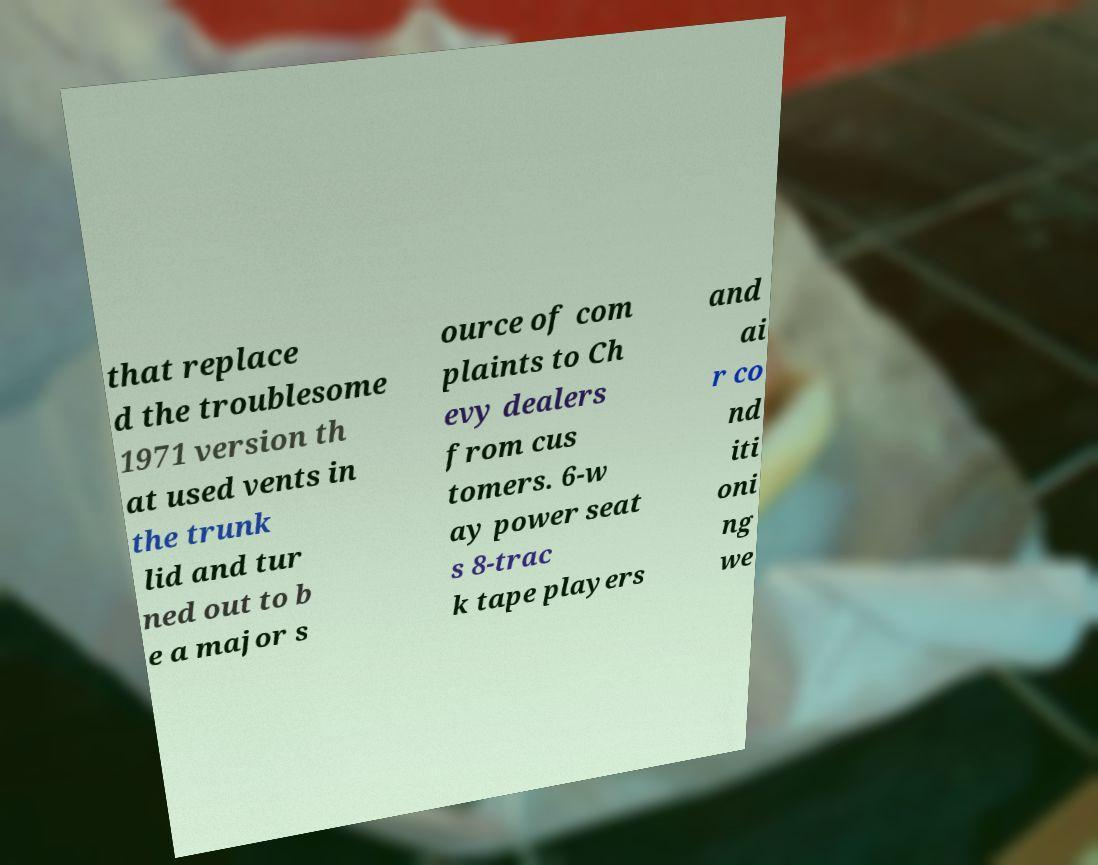There's text embedded in this image that I need extracted. Can you transcribe it verbatim? that replace d the troublesome 1971 version th at used vents in the trunk lid and tur ned out to b e a major s ource of com plaints to Ch evy dealers from cus tomers. 6-w ay power seat s 8-trac k tape players and ai r co nd iti oni ng we 